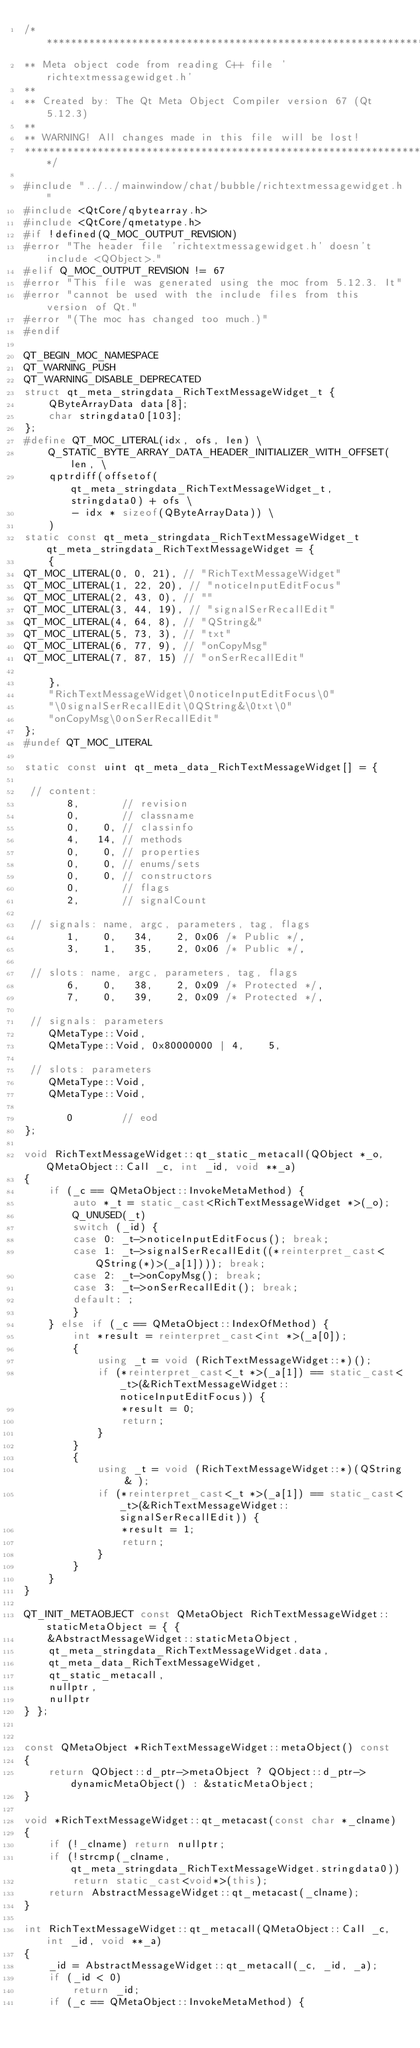<code> <loc_0><loc_0><loc_500><loc_500><_C++_>/****************************************************************************
** Meta object code from reading C++ file 'richtextmessagewidget.h'
**
** Created by: The Qt Meta Object Compiler version 67 (Qt 5.12.3)
**
** WARNING! All changes made in this file will be lost!
*****************************************************************************/

#include "../../mainwindow/chat/bubble/richtextmessagewidget.h"
#include <QtCore/qbytearray.h>
#include <QtCore/qmetatype.h>
#if !defined(Q_MOC_OUTPUT_REVISION)
#error "The header file 'richtextmessagewidget.h' doesn't include <QObject>."
#elif Q_MOC_OUTPUT_REVISION != 67
#error "This file was generated using the moc from 5.12.3. It"
#error "cannot be used with the include files from this version of Qt."
#error "(The moc has changed too much.)"
#endif

QT_BEGIN_MOC_NAMESPACE
QT_WARNING_PUSH
QT_WARNING_DISABLE_DEPRECATED
struct qt_meta_stringdata_RichTextMessageWidget_t {
    QByteArrayData data[8];
    char stringdata0[103];
};
#define QT_MOC_LITERAL(idx, ofs, len) \
    Q_STATIC_BYTE_ARRAY_DATA_HEADER_INITIALIZER_WITH_OFFSET(len, \
    qptrdiff(offsetof(qt_meta_stringdata_RichTextMessageWidget_t, stringdata0) + ofs \
        - idx * sizeof(QByteArrayData)) \
    )
static const qt_meta_stringdata_RichTextMessageWidget_t qt_meta_stringdata_RichTextMessageWidget = {
    {
QT_MOC_LITERAL(0, 0, 21), // "RichTextMessageWidget"
QT_MOC_LITERAL(1, 22, 20), // "noticeInputEditFocus"
QT_MOC_LITERAL(2, 43, 0), // ""
QT_MOC_LITERAL(3, 44, 19), // "signalSerRecallEdit"
QT_MOC_LITERAL(4, 64, 8), // "QString&"
QT_MOC_LITERAL(5, 73, 3), // "txt"
QT_MOC_LITERAL(6, 77, 9), // "onCopyMsg"
QT_MOC_LITERAL(7, 87, 15) // "onSerRecallEdit"

    },
    "RichTextMessageWidget\0noticeInputEditFocus\0"
    "\0signalSerRecallEdit\0QString&\0txt\0"
    "onCopyMsg\0onSerRecallEdit"
};
#undef QT_MOC_LITERAL

static const uint qt_meta_data_RichTextMessageWidget[] = {

 // content:
       8,       // revision
       0,       // classname
       0,    0, // classinfo
       4,   14, // methods
       0,    0, // properties
       0,    0, // enums/sets
       0,    0, // constructors
       0,       // flags
       2,       // signalCount

 // signals: name, argc, parameters, tag, flags
       1,    0,   34,    2, 0x06 /* Public */,
       3,    1,   35,    2, 0x06 /* Public */,

 // slots: name, argc, parameters, tag, flags
       6,    0,   38,    2, 0x09 /* Protected */,
       7,    0,   39,    2, 0x09 /* Protected */,

 // signals: parameters
    QMetaType::Void,
    QMetaType::Void, 0x80000000 | 4,    5,

 // slots: parameters
    QMetaType::Void,
    QMetaType::Void,

       0        // eod
};

void RichTextMessageWidget::qt_static_metacall(QObject *_o, QMetaObject::Call _c, int _id, void **_a)
{
    if (_c == QMetaObject::InvokeMetaMethod) {
        auto *_t = static_cast<RichTextMessageWidget *>(_o);
        Q_UNUSED(_t)
        switch (_id) {
        case 0: _t->noticeInputEditFocus(); break;
        case 1: _t->signalSerRecallEdit((*reinterpret_cast< QString(*)>(_a[1]))); break;
        case 2: _t->onCopyMsg(); break;
        case 3: _t->onSerRecallEdit(); break;
        default: ;
        }
    } else if (_c == QMetaObject::IndexOfMethod) {
        int *result = reinterpret_cast<int *>(_a[0]);
        {
            using _t = void (RichTextMessageWidget::*)();
            if (*reinterpret_cast<_t *>(_a[1]) == static_cast<_t>(&RichTextMessageWidget::noticeInputEditFocus)) {
                *result = 0;
                return;
            }
        }
        {
            using _t = void (RichTextMessageWidget::*)(QString & );
            if (*reinterpret_cast<_t *>(_a[1]) == static_cast<_t>(&RichTextMessageWidget::signalSerRecallEdit)) {
                *result = 1;
                return;
            }
        }
    }
}

QT_INIT_METAOBJECT const QMetaObject RichTextMessageWidget::staticMetaObject = { {
    &AbstractMessageWidget::staticMetaObject,
    qt_meta_stringdata_RichTextMessageWidget.data,
    qt_meta_data_RichTextMessageWidget,
    qt_static_metacall,
    nullptr,
    nullptr
} };


const QMetaObject *RichTextMessageWidget::metaObject() const
{
    return QObject::d_ptr->metaObject ? QObject::d_ptr->dynamicMetaObject() : &staticMetaObject;
}

void *RichTextMessageWidget::qt_metacast(const char *_clname)
{
    if (!_clname) return nullptr;
    if (!strcmp(_clname, qt_meta_stringdata_RichTextMessageWidget.stringdata0))
        return static_cast<void*>(this);
    return AbstractMessageWidget::qt_metacast(_clname);
}

int RichTextMessageWidget::qt_metacall(QMetaObject::Call _c, int _id, void **_a)
{
    _id = AbstractMessageWidget::qt_metacall(_c, _id, _a);
    if (_id < 0)
        return _id;
    if (_c == QMetaObject::InvokeMetaMethod) {</code> 